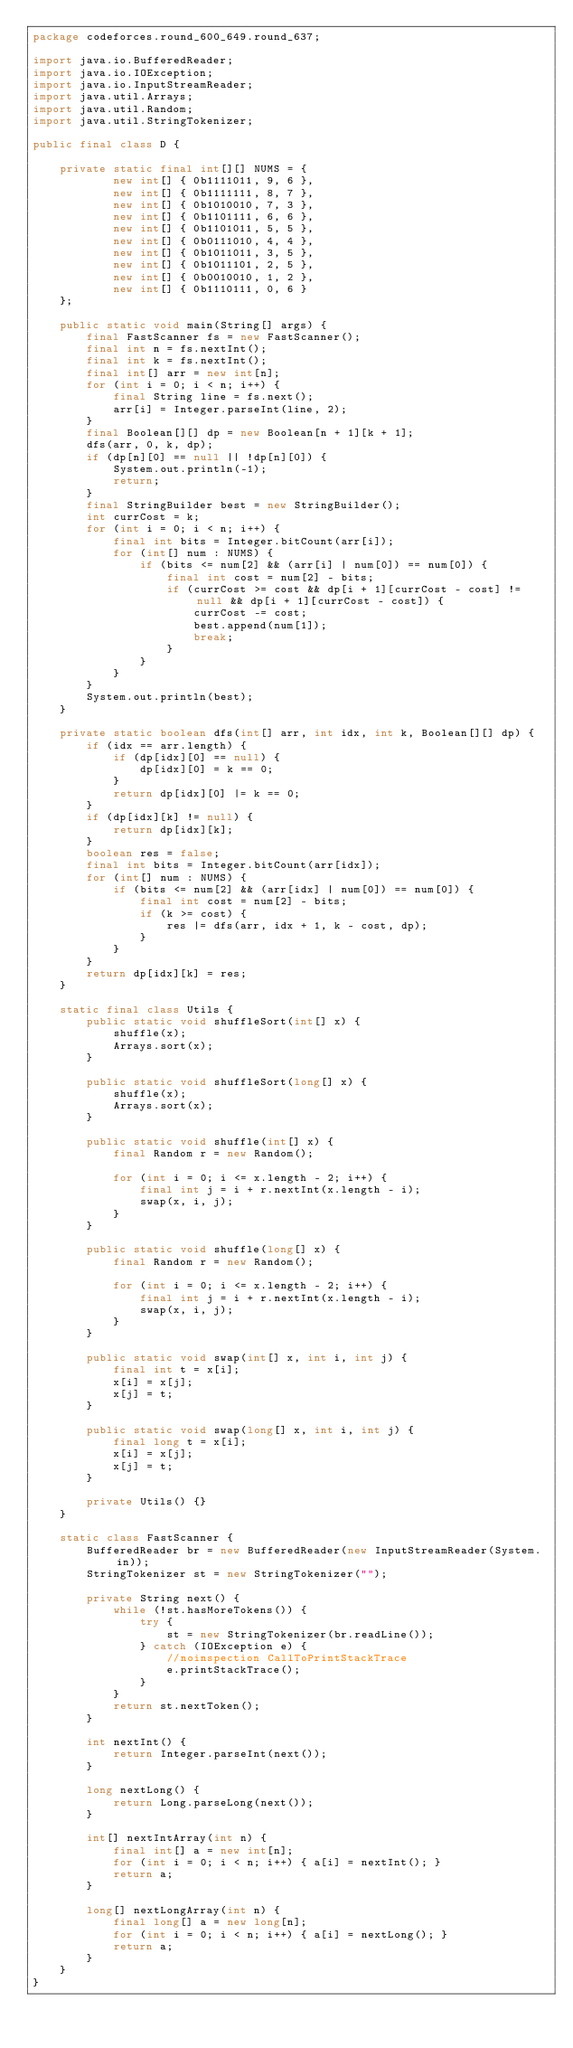<code> <loc_0><loc_0><loc_500><loc_500><_Java_>package codeforces.round_600_649.round_637;

import java.io.BufferedReader;
import java.io.IOException;
import java.io.InputStreamReader;
import java.util.Arrays;
import java.util.Random;
import java.util.StringTokenizer;

public final class D {

    private static final int[][] NUMS = {
            new int[] { 0b1111011, 9, 6 },
            new int[] { 0b1111111, 8, 7 },
            new int[] { 0b1010010, 7, 3 },
            new int[] { 0b1101111, 6, 6 },
            new int[] { 0b1101011, 5, 5 },
            new int[] { 0b0111010, 4, 4 },
            new int[] { 0b1011011, 3, 5 },
            new int[] { 0b1011101, 2, 5 },
            new int[] { 0b0010010, 1, 2 },
            new int[] { 0b1110111, 0, 6 }
    };

    public static void main(String[] args) {
        final FastScanner fs = new FastScanner();
        final int n = fs.nextInt();
        final int k = fs.nextInt();
        final int[] arr = new int[n];
        for (int i = 0; i < n; i++) {
            final String line = fs.next();
            arr[i] = Integer.parseInt(line, 2);
        }
        final Boolean[][] dp = new Boolean[n + 1][k + 1];
        dfs(arr, 0, k, dp);
        if (dp[n][0] == null || !dp[n][0]) {
            System.out.println(-1);
            return;
        }
        final StringBuilder best = new StringBuilder();
        int currCost = k;
        for (int i = 0; i < n; i++) {
            final int bits = Integer.bitCount(arr[i]);
            for (int[] num : NUMS) {
                if (bits <= num[2] && (arr[i] | num[0]) == num[0]) {
                    final int cost = num[2] - bits;
                    if (currCost >= cost && dp[i + 1][currCost - cost] != null && dp[i + 1][currCost - cost]) {
                        currCost -= cost;
                        best.append(num[1]);
                        break;
                    }
                }
            }
        }
        System.out.println(best);
    }

    private static boolean dfs(int[] arr, int idx, int k, Boolean[][] dp) {
        if (idx == arr.length) {
            if (dp[idx][0] == null) {
                dp[idx][0] = k == 0;
            }
            return dp[idx][0] |= k == 0;
        }
        if (dp[idx][k] != null) {
            return dp[idx][k];
        }
        boolean res = false;
        final int bits = Integer.bitCount(arr[idx]);
        for (int[] num : NUMS) {
            if (bits <= num[2] && (arr[idx] | num[0]) == num[0]) {
                final int cost = num[2] - bits;
                if (k >= cost) {
                    res |= dfs(arr, idx + 1, k - cost, dp);
                }
            }
        }
        return dp[idx][k] = res;
    }

    static final class Utils {
        public static void shuffleSort(int[] x) {
            shuffle(x);
            Arrays.sort(x);
        }

        public static void shuffleSort(long[] x) {
            shuffle(x);
            Arrays.sort(x);
        }

        public static void shuffle(int[] x) {
            final Random r = new Random();

            for (int i = 0; i <= x.length - 2; i++) {
                final int j = i + r.nextInt(x.length - i);
                swap(x, i, j);
            }
        }

        public static void shuffle(long[] x) {
            final Random r = new Random();

            for (int i = 0; i <= x.length - 2; i++) {
                final int j = i + r.nextInt(x.length - i);
                swap(x, i, j);
            }
        }

        public static void swap(int[] x, int i, int j) {
            final int t = x[i];
            x[i] = x[j];
            x[j] = t;
        }

        public static void swap(long[] x, int i, int j) {
            final long t = x[i];
            x[i] = x[j];
            x[j] = t;
        }

        private Utils() {}
    }

    static class FastScanner {
        BufferedReader br = new BufferedReader(new InputStreamReader(System.in));
        StringTokenizer st = new StringTokenizer("");

        private String next() {
            while (!st.hasMoreTokens()) {
                try {
                    st = new StringTokenizer(br.readLine());
                } catch (IOException e) {
                    //noinspection CallToPrintStackTrace
                    e.printStackTrace();
                }
            }
            return st.nextToken();
        }

        int nextInt() {
            return Integer.parseInt(next());
        }

        long nextLong() {
            return Long.parseLong(next());
        }

        int[] nextIntArray(int n) {
            final int[] a = new int[n];
            for (int i = 0; i < n; i++) { a[i] = nextInt(); }
            return a;
        }

        long[] nextLongArray(int n) {
            final long[] a = new long[n];
            for (int i = 0; i < n; i++) { a[i] = nextLong(); }
            return a;
        }
    }
}
</code> 